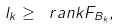Convert formula to latex. <formula><loc_0><loc_0><loc_500><loc_500>l _ { k } \geq \ r a n k F _ { B _ { k } } ,</formula> 